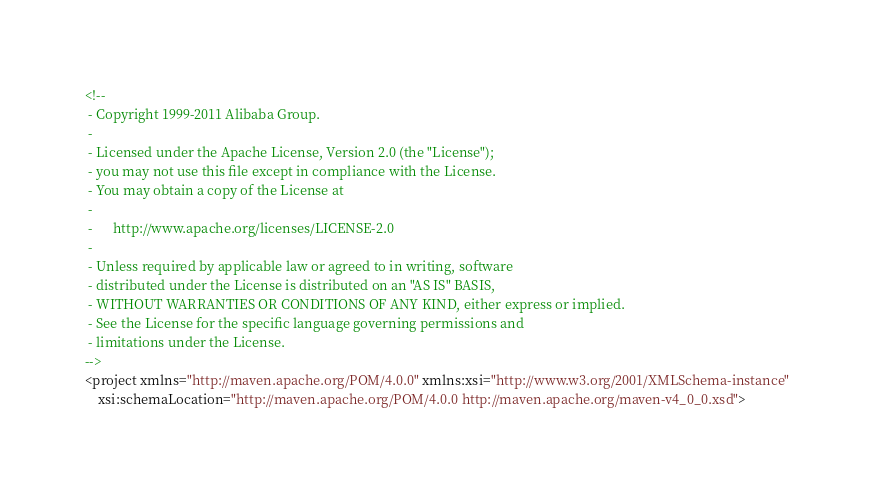<code> <loc_0><loc_0><loc_500><loc_500><_XML_><!--
 - Copyright 1999-2011 Alibaba Group.
 -  
 - Licensed under the Apache License, Version 2.0 (the "License");
 - you may not use this file except in compliance with the License.
 - You may obtain a copy of the License at
 -  
 -      http://www.apache.org/licenses/LICENSE-2.0
 -  
 - Unless required by applicable law or agreed to in writing, software
 - distributed under the License is distributed on an "AS IS" BASIS,
 - WITHOUT WARRANTIES OR CONDITIONS OF ANY KIND, either express or implied.
 - See the License for the specific language governing permissions and
 - limitations under the License.
-->
<project xmlns="http://maven.apache.org/POM/4.0.0" xmlns:xsi="http://www.w3.org/2001/XMLSchema-instance"
	xsi:schemaLocation="http://maven.apache.org/POM/4.0.0 http://maven.apache.org/maven-v4_0_0.xsd"></code> 